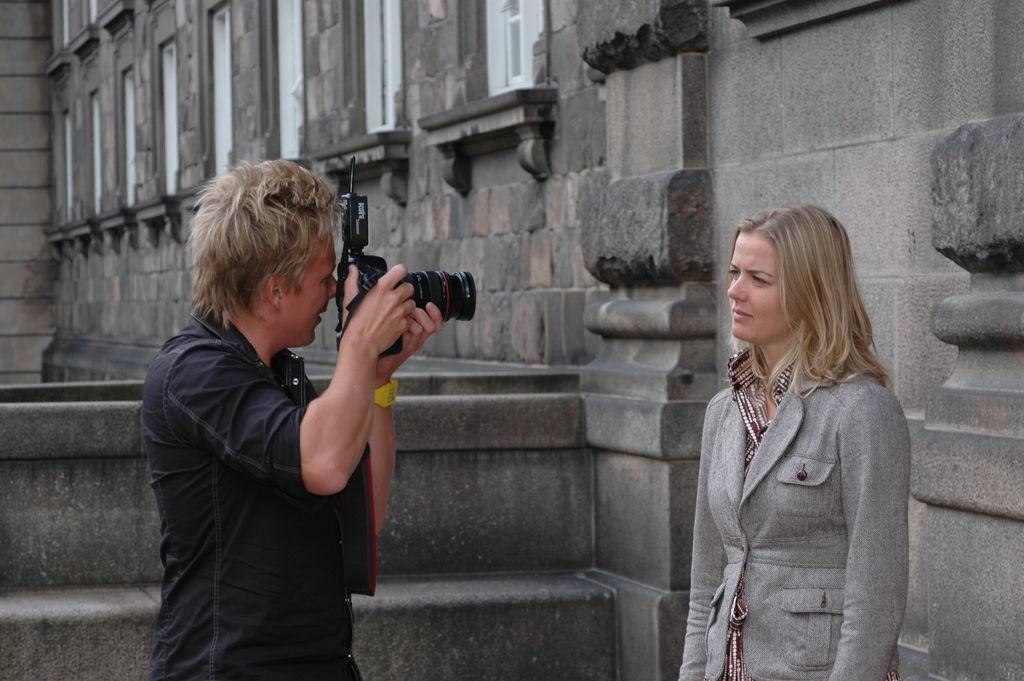How many people are present in the image? There are two people in the image. Can you describe the gender of one of the individuals? One person is a man. What is the man holding in the image? The man is holding a camera. What is the man doing with the camera? The man is clicking a picture of a woman. What can be seen in the background of the image? There is a building in the background of the image. Can you tell me how many snails are crawling on the woman's shoulder in the image? There are no snails present in the image; the man is taking a picture of a woman, and there is no mention of snails. 